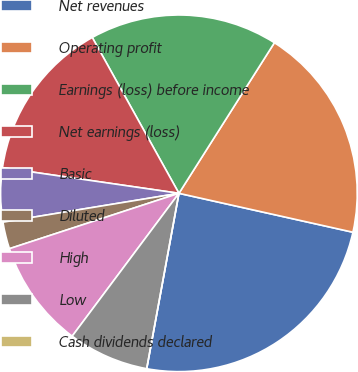Convert chart. <chart><loc_0><loc_0><loc_500><loc_500><pie_chart><fcel>Net revenues<fcel>Operating profit<fcel>Earnings (loss) before income<fcel>Net earnings (loss)<fcel>Basic<fcel>Diluted<fcel>High<fcel>Low<fcel>Cash dividends declared<nl><fcel>24.39%<fcel>19.51%<fcel>17.07%<fcel>14.63%<fcel>4.88%<fcel>2.44%<fcel>9.76%<fcel>7.32%<fcel>0.0%<nl></chart> 